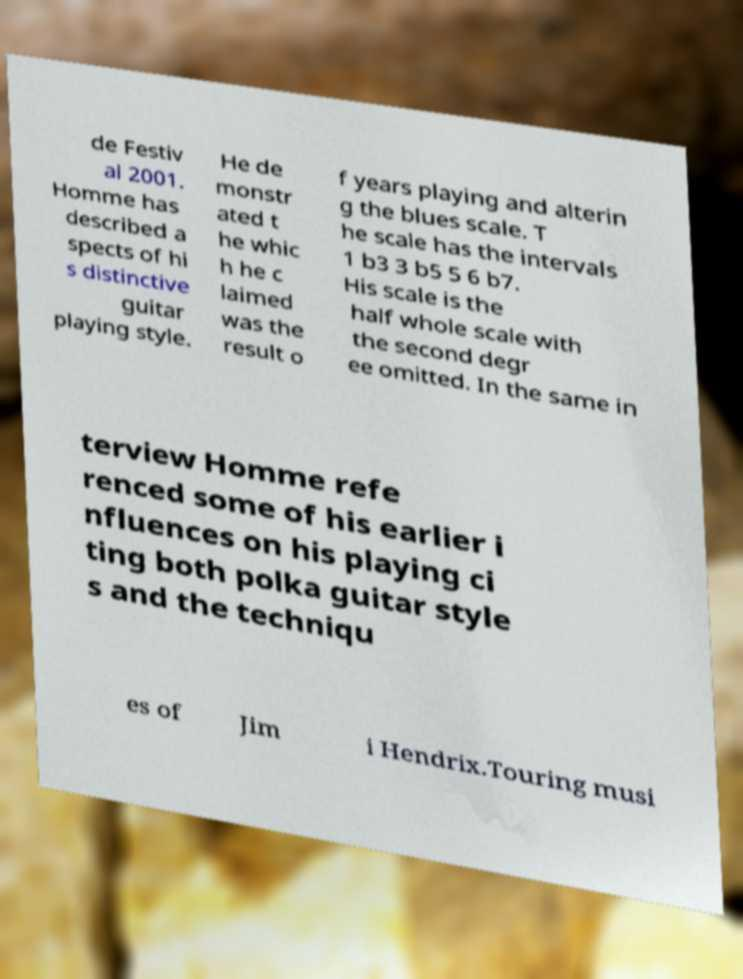Can you read and provide the text displayed in the image?This photo seems to have some interesting text. Can you extract and type it out for me? de Festiv al 2001. Homme has described a spects of hi s distinctive guitar playing style. He de monstr ated t he whic h he c laimed was the result o f years playing and alterin g the blues scale. T he scale has the intervals 1 b3 3 b5 5 6 b7. His scale is the half whole scale with the second degr ee omitted. In the same in terview Homme refe renced some of his earlier i nfluences on his playing ci ting both polka guitar style s and the techniqu es of Jim i Hendrix.Touring musi 